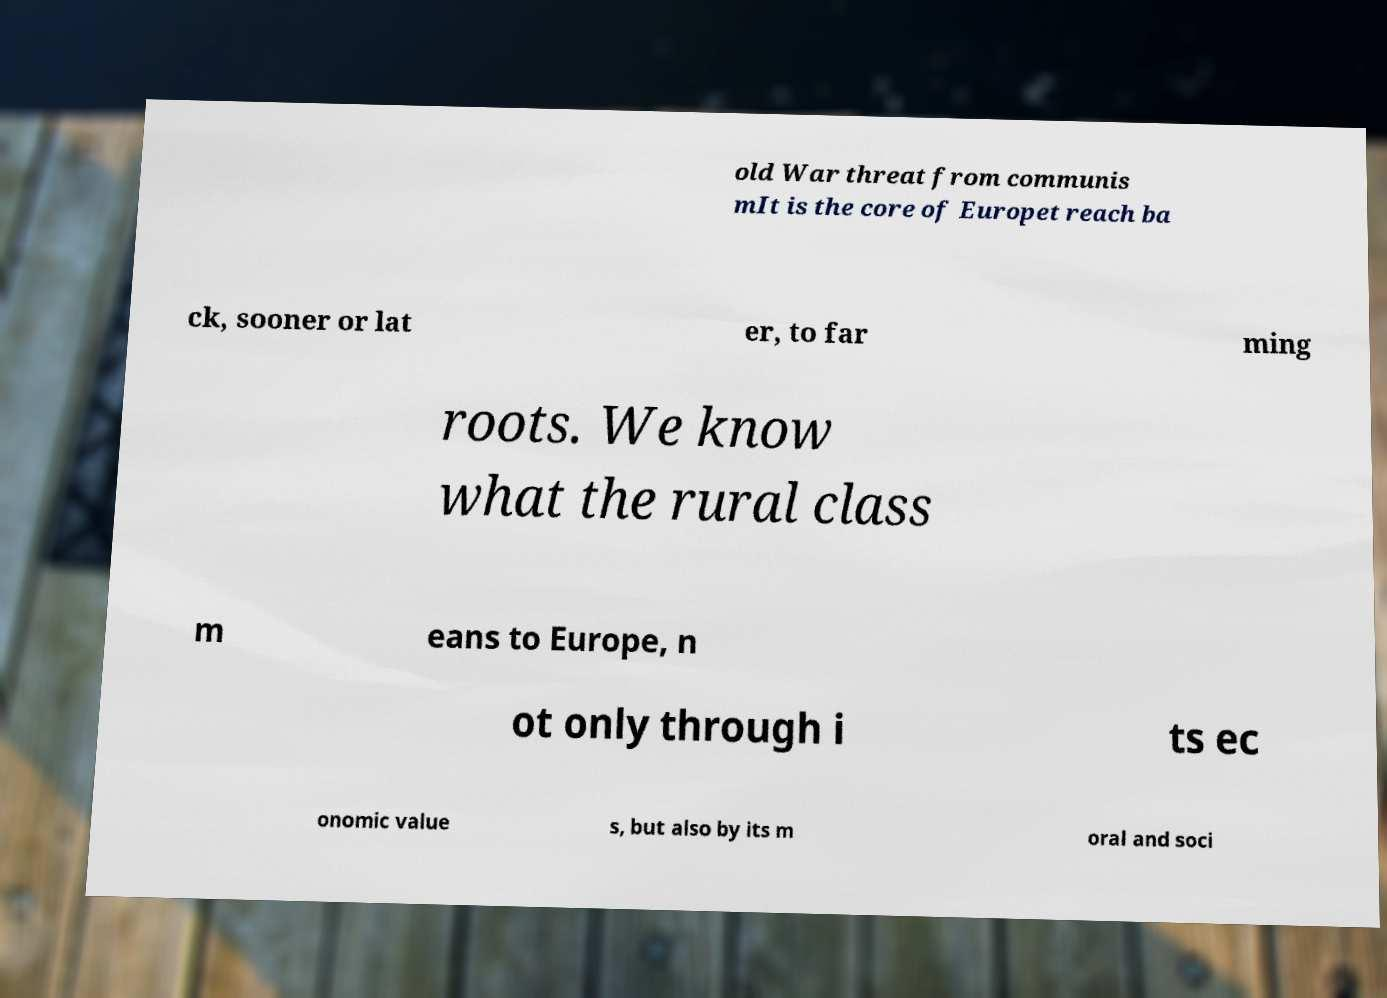For documentation purposes, I need the text within this image transcribed. Could you provide that? old War threat from communis mIt is the core of Europet reach ba ck, sooner or lat er, to far ming roots. We know what the rural class m eans to Europe, n ot only through i ts ec onomic value s, but also by its m oral and soci 